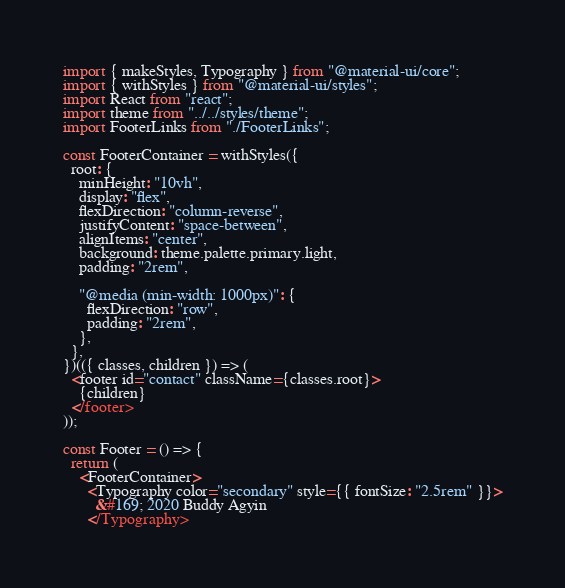<code> <loc_0><loc_0><loc_500><loc_500><_JavaScript_>import { makeStyles, Typography } from "@material-ui/core";
import { withStyles } from "@material-ui/styles";
import React from "react";
import theme from "../../styles/theme";
import FooterLinks from "./FooterLinks";

const FooterContainer = withStyles({
  root: {
    minHeight: "10vh",
    display: "flex",
    flexDirection: "column-reverse",
    justifyContent: "space-between",
    alignItems: "center",
    background: theme.palette.primary.light,
    padding: "2rem",

    "@media (min-width: 1000px)": {
      flexDirection: "row",
      padding: "2rem",
    },
  },
})(({ classes, children }) => (
  <footer id="contact" className={classes.root}>
    {children}
  </footer>
));

const Footer = () => {
  return (
    <FooterContainer>
      <Typography color="secondary" style={{ fontSize: "2.5rem" }}>
        &#169; 2020 Buddy Agyin
      </Typography></code> 